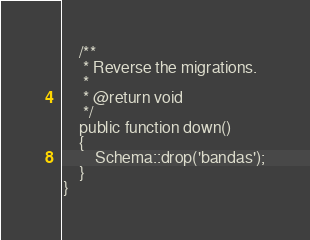<code> <loc_0><loc_0><loc_500><loc_500><_PHP_>    /**
     * Reverse the migrations.
     *
     * @return void
     */
    public function down()
    {
        Schema::drop('bandas');
    }
}
</code> 